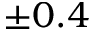Convert formula to latex. <formula><loc_0><loc_0><loc_500><loc_500>\pm 0 . 4</formula> 